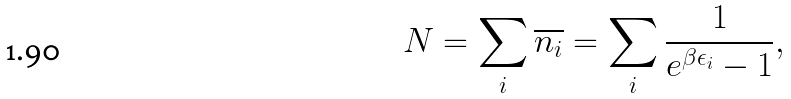Convert formula to latex. <formula><loc_0><loc_0><loc_500><loc_500>N = \sum _ { i } \overline { n _ { i } } = \sum _ { i } \frac { 1 } { e ^ { \beta \epsilon _ { i } } - 1 } ,</formula> 